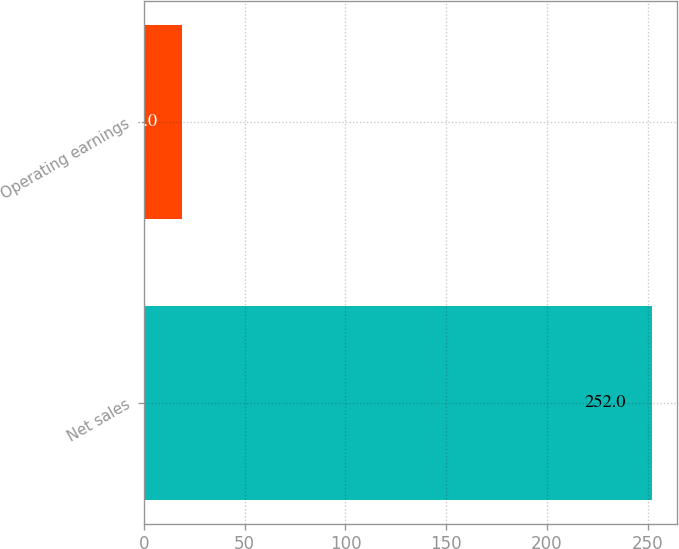Convert chart. <chart><loc_0><loc_0><loc_500><loc_500><bar_chart><fcel>Net sales<fcel>Operating earnings<nl><fcel>252<fcel>19<nl></chart> 